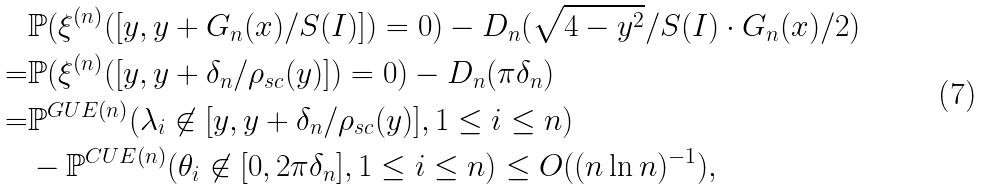<formula> <loc_0><loc_0><loc_500><loc_500>& \mathbb { P } ( \xi ^ { ( n ) } ( [ y , y + G _ { n } ( x ) / S ( I ) ] ) = 0 ) - D _ { n } ( \sqrt { 4 - y ^ { 2 } } / S ( I ) \cdot G _ { n } ( x ) / 2 ) \\ = & \mathbb { P } ( \xi ^ { ( n ) } ( [ y , y + \delta _ { n } / \rho _ { s c } ( y ) ] ) = 0 ) - D _ { n } ( \pi \delta _ { n } ) \\ = & \mathbb { P } ^ { G U E ( n ) } ( \lambda _ { i } \not \in [ y , y + \delta _ { n } / \rho _ { s c } ( y ) ] , 1 \leq i \leq n ) \\ & - \mathbb { P } ^ { C U E ( n ) } ( \theta _ { i } \not \in [ 0 , 2 \pi \delta _ { n } ] , 1 \leq i \leq n ) \leq O ( ( n \ln n ) ^ { - 1 } ) ,</formula> 